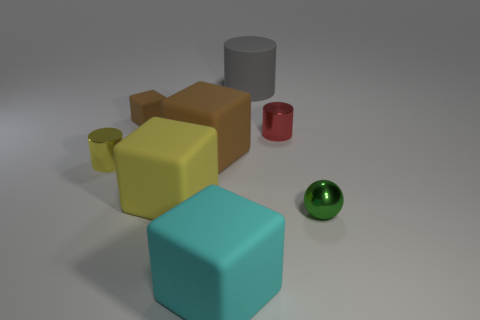Do the cyan object and the big gray matte object have the same shape?
Offer a very short reply. No. There is a matte object that is both to the left of the large gray matte cylinder and behind the tiny red object; what size is it?
Offer a terse response. Small. There is another tiny object that is the same shape as the cyan object; what is it made of?
Your response must be concise. Rubber. What is the material of the tiny brown thing that is behind the metal thing that is on the left side of the tiny cube?
Keep it short and to the point. Rubber. There is a big brown matte thing; is its shape the same as the brown rubber thing left of the big brown rubber thing?
Provide a succinct answer. Yes. How many rubber things are cylinders or purple spheres?
Your answer should be very brief. 1. What is the color of the shiny cylinder that is in front of the tiny cylinder to the right of the big rubber thing behind the small brown rubber object?
Ensure brevity in your answer.  Yellow. How many other objects are there of the same material as the gray cylinder?
Ensure brevity in your answer.  4. There is a tiny metal thing that is behind the big brown rubber block; is it the same shape as the yellow matte object?
Ensure brevity in your answer.  No. What number of tiny things are blue shiny spheres or yellow rubber things?
Offer a very short reply. 0. 